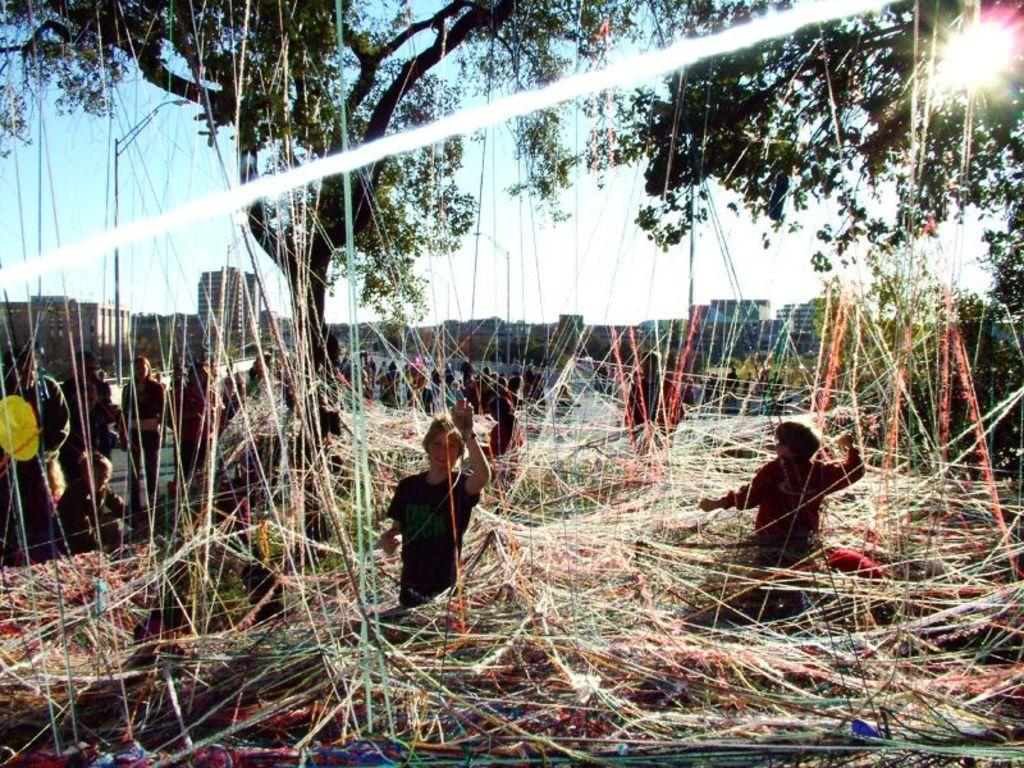Please provide a concise description of this image. There are groups of people standing. I think these are the threads. I can see a tree with branches and leaves. In the background, these look like the buildings. 